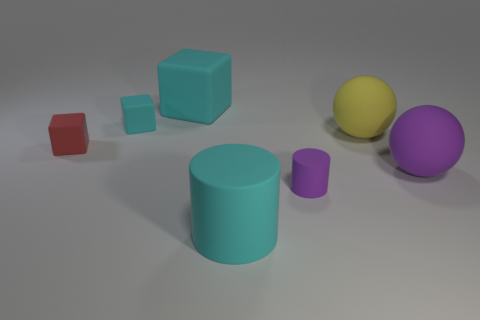Add 2 big green things. How many objects exist? 9 Subtract all cylinders. How many objects are left? 5 Subtract 1 yellow balls. How many objects are left? 6 Subtract all balls. Subtract all yellow rubber balls. How many objects are left? 4 Add 1 yellow spheres. How many yellow spheres are left? 2 Add 5 small red blocks. How many small red blocks exist? 6 